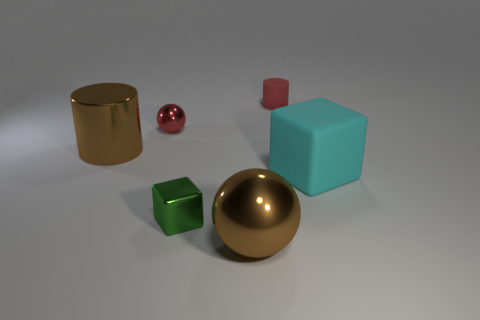Add 4 tiny cylinders. How many objects exist? 10 Subtract all balls. How many objects are left? 4 Subtract all cyan things. Subtract all rubber cylinders. How many objects are left? 4 Add 5 large shiny things. How many large shiny things are left? 7 Add 3 brown rubber spheres. How many brown rubber spheres exist? 3 Subtract 1 red spheres. How many objects are left? 5 